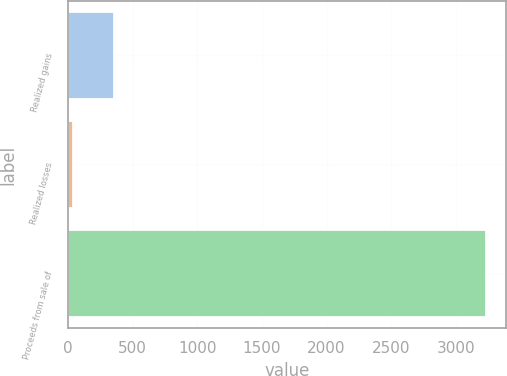Convert chart to OTSL. <chart><loc_0><loc_0><loc_500><loc_500><bar_chart><fcel>Realized gains<fcel>Realized losses<fcel>Proceeds from sale of<nl><fcel>357.3<fcel>38<fcel>3231<nl></chart> 